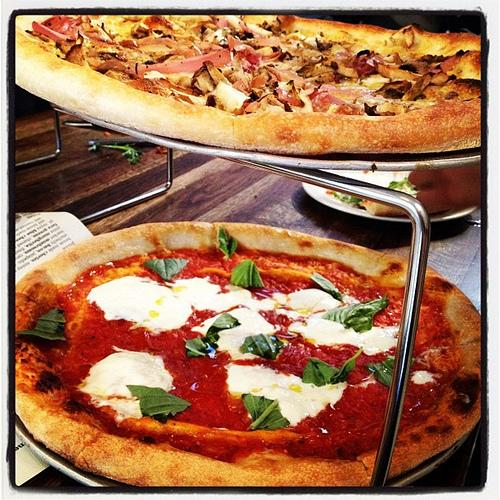Identify the key components of the image that relate to pizza and dining. Key components include the two pizzas with various toppings, the bi-level serving rack, a hand reaching for a pizza slice, and the wooden table. Explain the scene in the image, highlighting the main objects and their attributes. The scene shows two pizzas with different toppings, such as cheese, basil, ham, and mushrooms, on a double-layer wire rack atop a wooden table, with a person taking a slice of pizza from a nearby plate. In one sentence, summarize the primary contents of the image. The photo shows two different pizzas on a wire display rack, with various toppings such as cheese, ricotta, mushroom, basil leaves, and ham, on a wooden table. What are some striking visual features in the image? The striking visual features include the bright red pizza sauce, fresh green basil leaves, round pizza shapes, and the stainless steel wire display rack holding the pizzas. Describe the colors and textures present in the image. There are vibrant colors like bright red pizza sauce, fresh green basil leaves, and golden brown crust, along with the creamy texture of mozzarella and shiny surface of the wire display rack. Describe the setting where the pizzas are placed. The pizzas are placed on a two-tier stainless steel wire display rack, set atop a wood grain table with a mix of dark and light areas. Give a succinct description of the most noticeable toppings on the pizzas. The pizzas feature prominent toppings such as fresh basil leaves, melted mozzarella, red sauce, mushroom pieces, and ham slices. Provide a brief overview of the key elements in the image. Two pizzas, one with greens and one with meat and mushrooms, are served on a bi-level wire rack on a wooden table, with a hand reaching for a slice of pizza from a small white plate. What are some key details about the toppings on the pizzas? Key details include fresh green basil leaves, melted mozzarella, bright red pizza sauce, golden brown crust, mushroom pieces, ham slices, and red onion on the pizzas. Mention the different types of pizzas shown in the image. The image features a mozzarella and basil pizza with tomato sauce and a meat pizza with mushrooms, onions, and ham on a wooden table. 